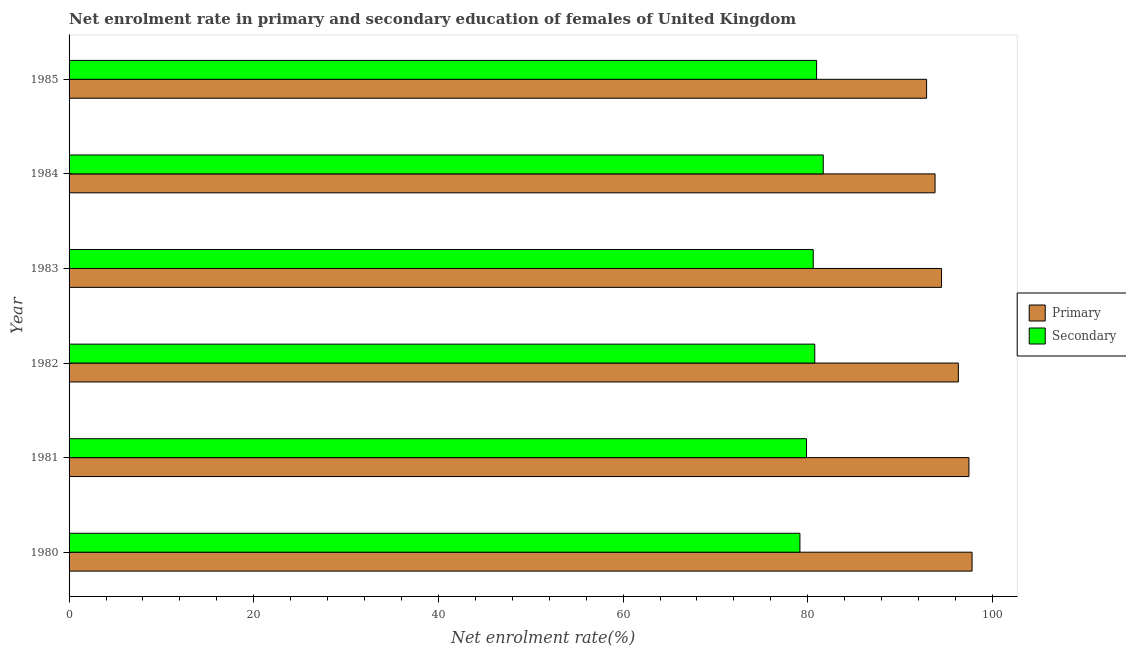How many groups of bars are there?
Your response must be concise. 6. What is the label of the 1st group of bars from the top?
Provide a short and direct response. 1985. What is the enrollment rate in primary education in 1982?
Your answer should be very brief. 96.31. Across all years, what is the maximum enrollment rate in primary education?
Provide a succinct answer. 97.8. Across all years, what is the minimum enrollment rate in secondary education?
Offer a terse response. 79.15. In which year was the enrollment rate in secondary education maximum?
Keep it short and to the point. 1984. In which year was the enrollment rate in secondary education minimum?
Offer a very short reply. 1980. What is the total enrollment rate in secondary education in the graph?
Your answer should be compact. 483.01. What is the difference between the enrollment rate in primary education in 1981 and that in 1983?
Your answer should be compact. 2.97. What is the difference between the enrollment rate in primary education in 1981 and the enrollment rate in secondary education in 1980?
Offer a terse response. 18.3. What is the average enrollment rate in secondary education per year?
Your response must be concise. 80.5. In the year 1981, what is the difference between the enrollment rate in secondary education and enrollment rate in primary education?
Provide a short and direct response. -17.59. What is the ratio of the enrollment rate in secondary education in 1984 to that in 1985?
Your answer should be compact. 1.01. Is the difference between the enrollment rate in secondary education in 1981 and 1984 greater than the difference between the enrollment rate in primary education in 1981 and 1984?
Provide a short and direct response. No. What is the difference between the highest and the second highest enrollment rate in primary education?
Your answer should be compact. 0.34. What is the difference between the highest and the lowest enrollment rate in primary education?
Your response must be concise. 4.92. In how many years, is the enrollment rate in primary education greater than the average enrollment rate in primary education taken over all years?
Provide a short and direct response. 3. Is the sum of the enrollment rate in secondary education in 1980 and 1985 greater than the maximum enrollment rate in primary education across all years?
Make the answer very short. Yes. What does the 1st bar from the top in 1983 represents?
Your answer should be very brief. Secondary. What does the 1st bar from the bottom in 1982 represents?
Offer a very short reply. Primary. Does the graph contain grids?
Provide a short and direct response. No. How are the legend labels stacked?
Provide a succinct answer. Vertical. What is the title of the graph?
Your answer should be very brief. Net enrolment rate in primary and secondary education of females of United Kingdom. What is the label or title of the X-axis?
Ensure brevity in your answer.  Net enrolment rate(%). What is the label or title of the Y-axis?
Your answer should be compact. Year. What is the Net enrolment rate(%) in Primary in 1980?
Keep it short and to the point. 97.8. What is the Net enrolment rate(%) of Secondary in 1980?
Offer a very short reply. 79.15. What is the Net enrolment rate(%) in Primary in 1981?
Make the answer very short. 97.46. What is the Net enrolment rate(%) in Secondary in 1981?
Provide a succinct answer. 79.87. What is the Net enrolment rate(%) in Primary in 1982?
Ensure brevity in your answer.  96.31. What is the Net enrolment rate(%) of Secondary in 1982?
Your answer should be very brief. 80.76. What is the Net enrolment rate(%) of Primary in 1983?
Your answer should be very brief. 94.49. What is the Net enrolment rate(%) in Secondary in 1983?
Provide a short and direct response. 80.6. What is the Net enrolment rate(%) in Primary in 1984?
Make the answer very short. 93.79. What is the Net enrolment rate(%) in Secondary in 1984?
Ensure brevity in your answer.  81.68. What is the Net enrolment rate(%) of Primary in 1985?
Offer a very short reply. 92.87. What is the Net enrolment rate(%) in Secondary in 1985?
Keep it short and to the point. 80.96. Across all years, what is the maximum Net enrolment rate(%) of Primary?
Your answer should be very brief. 97.8. Across all years, what is the maximum Net enrolment rate(%) of Secondary?
Ensure brevity in your answer.  81.68. Across all years, what is the minimum Net enrolment rate(%) of Primary?
Offer a very short reply. 92.87. Across all years, what is the minimum Net enrolment rate(%) in Secondary?
Make the answer very short. 79.15. What is the total Net enrolment rate(%) in Primary in the graph?
Make the answer very short. 572.72. What is the total Net enrolment rate(%) of Secondary in the graph?
Your answer should be compact. 483.01. What is the difference between the Net enrolment rate(%) of Primary in 1980 and that in 1981?
Provide a short and direct response. 0.34. What is the difference between the Net enrolment rate(%) in Secondary in 1980 and that in 1981?
Make the answer very short. -0.71. What is the difference between the Net enrolment rate(%) in Primary in 1980 and that in 1982?
Your response must be concise. 1.48. What is the difference between the Net enrolment rate(%) in Secondary in 1980 and that in 1982?
Offer a very short reply. -1.61. What is the difference between the Net enrolment rate(%) of Primary in 1980 and that in 1983?
Ensure brevity in your answer.  3.31. What is the difference between the Net enrolment rate(%) in Secondary in 1980 and that in 1983?
Offer a terse response. -1.44. What is the difference between the Net enrolment rate(%) in Primary in 1980 and that in 1984?
Your answer should be very brief. 4.01. What is the difference between the Net enrolment rate(%) of Secondary in 1980 and that in 1984?
Your response must be concise. -2.53. What is the difference between the Net enrolment rate(%) in Primary in 1980 and that in 1985?
Your answer should be compact. 4.92. What is the difference between the Net enrolment rate(%) in Secondary in 1980 and that in 1985?
Offer a very short reply. -1.8. What is the difference between the Net enrolment rate(%) of Primary in 1981 and that in 1982?
Make the answer very short. 1.15. What is the difference between the Net enrolment rate(%) of Secondary in 1981 and that in 1982?
Your answer should be compact. -0.9. What is the difference between the Net enrolment rate(%) in Primary in 1981 and that in 1983?
Keep it short and to the point. 2.97. What is the difference between the Net enrolment rate(%) in Secondary in 1981 and that in 1983?
Make the answer very short. -0.73. What is the difference between the Net enrolment rate(%) in Primary in 1981 and that in 1984?
Your response must be concise. 3.67. What is the difference between the Net enrolment rate(%) in Secondary in 1981 and that in 1984?
Ensure brevity in your answer.  -1.81. What is the difference between the Net enrolment rate(%) of Primary in 1981 and that in 1985?
Provide a short and direct response. 4.59. What is the difference between the Net enrolment rate(%) of Secondary in 1981 and that in 1985?
Your response must be concise. -1.09. What is the difference between the Net enrolment rate(%) in Primary in 1982 and that in 1983?
Ensure brevity in your answer.  1.82. What is the difference between the Net enrolment rate(%) of Secondary in 1982 and that in 1983?
Keep it short and to the point. 0.17. What is the difference between the Net enrolment rate(%) in Primary in 1982 and that in 1984?
Provide a short and direct response. 2.52. What is the difference between the Net enrolment rate(%) in Secondary in 1982 and that in 1984?
Offer a very short reply. -0.92. What is the difference between the Net enrolment rate(%) of Primary in 1982 and that in 1985?
Keep it short and to the point. 3.44. What is the difference between the Net enrolment rate(%) of Secondary in 1982 and that in 1985?
Your response must be concise. -0.19. What is the difference between the Net enrolment rate(%) in Primary in 1983 and that in 1984?
Offer a very short reply. 0.7. What is the difference between the Net enrolment rate(%) in Secondary in 1983 and that in 1984?
Provide a succinct answer. -1.08. What is the difference between the Net enrolment rate(%) of Primary in 1983 and that in 1985?
Provide a succinct answer. 1.62. What is the difference between the Net enrolment rate(%) in Secondary in 1983 and that in 1985?
Offer a terse response. -0.36. What is the difference between the Net enrolment rate(%) in Primary in 1984 and that in 1985?
Keep it short and to the point. 0.91. What is the difference between the Net enrolment rate(%) in Secondary in 1984 and that in 1985?
Your response must be concise. 0.72. What is the difference between the Net enrolment rate(%) in Primary in 1980 and the Net enrolment rate(%) in Secondary in 1981?
Make the answer very short. 17.93. What is the difference between the Net enrolment rate(%) of Primary in 1980 and the Net enrolment rate(%) of Secondary in 1982?
Keep it short and to the point. 17.03. What is the difference between the Net enrolment rate(%) in Primary in 1980 and the Net enrolment rate(%) in Secondary in 1983?
Provide a short and direct response. 17.2. What is the difference between the Net enrolment rate(%) of Primary in 1980 and the Net enrolment rate(%) of Secondary in 1984?
Provide a succinct answer. 16.12. What is the difference between the Net enrolment rate(%) of Primary in 1980 and the Net enrolment rate(%) of Secondary in 1985?
Ensure brevity in your answer.  16.84. What is the difference between the Net enrolment rate(%) of Primary in 1981 and the Net enrolment rate(%) of Secondary in 1982?
Your answer should be compact. 16.69. What is the difference between the Net enrolment rate(%) of Primary in 1981 and the Net enrolment rate(%) of Secondary in 1983?
Your answer should be compact. 16.86. What is the difference between the Net enrolment rate(%) in Primary in 1981 and the Net enrolment rate(%) in Secondary in 1984?
Provide a short and direct response. 15.78. What is the difference between the Net enrolment rate(%) of Primary in 1981 and the Net enrolment rate(%) of Secondary in 1985?
Keep it short and to the point. 16.5. What is the difference between the Net enrolment rate(%) of Primary in 1982 and the Net enrolment rate(%) of Secondary in 1983?
Provide a short and direct response. 15.72. What is the difference between the Net enrolment rate(%) in Primary in 1982 and the Net enrolment rate(%) in Secondary in 1984?
Keep it short and to the point. 14.63. What is the difference between the Net enrolment rate(%) of Primary in 1982 and the Net enrolment rate(%) of Secondary in 1985?
Offer a very short reply. 15.35. What is the difference between the Net enrolment rate(%) in Primary in 1983 and the Net enrolment rate(%) in Secondary in 1984?
Your answer should be very brief. 12.81. What is the difference between the Net enrolment rate(%) of Primary in 1983 and the Net enrolment rate(%) of Secondary in 1985?
Keep it short and to the point. 13.53. What is the difference between the Net enrolment rate(%) in Primary in 1984 and the Net enrolment rate(%) in Secondary in 1985?
Offer a very short reply. 12.83. What is the average Net enrolment rate(%) of Primary per year?
Provide a short and direct response. 95.45. What is the average Net enrolment rate(%) of Secondary per year?
Keep it short and to the point. 80.5. In the year 1980, what is the difference between the Net enrolment rate(%) in Primary and Net enrolment rate(%) in Secondary?
Your answer should be very brief. 18.64. In the year 1981, what is the difference between the Net enrolment rate(%) in Primary and Net enrolment rate(%) in Secondary?
Provide a succinct answer. 17.59. In the year 1982, what is the difference between the Net enrolment rate(%) of Primary and Net enrolment rate(%) of Secondary?
Keep it short and to the point. 15.55. In the year 1983, what is the difference between the Net enrolment rate(%) in Primary and Net enrolment rate(%) in Secondary?
Your answer should be very brief. 13.9. In the year 1984, what is the difference between the Net enrolment rate(%) of Primary and Net enrolment rate(%) of Secondary?
Your answer should be compact. 12.11. In the year 1985, what is the difference between the Net enrolment rate(%) of Primary and Net enrolment rate(%) of Secondary?
Make the answer very short. 11.92. What is the ratio of the Net enrolment rate(%) in Secondary in 1980 to that in 1981?
Your answer should be very brief. 0.99. What is the ratio of the Net enrolment rate(%) of Primary in 1980 to that in 1982?
Your answer should be very brief. 1.02. What is the ratio of the Net enrolment rate(%) of Secondary in 1980 to that in 1982?
Ensure brevity in your answer.  0.98. What is the ratio of the Net enrolment rate(%) of Primary in 1980 to that in 1983?
Your answer should be compact. 1.03. What is the ratio of the Net enrolment rate(%) in Secondary in 1980 to that in 1983?
Ensure brevity in your answer.  0.98. What is the ratio of the Net enrolment rate(%) in Primary in 1980 to that in 1984?
Provide a short and direct response. 1.04. What is the ratio of the Net enrolment rate(%) in Secondary in 1980 to that in 1984?
Make the answer very short. 0.97. What is the ratio of the Net enrolment rate(%) of Primary in 1980 to that in 1985?
Your answer should be very brief. 1.05. What is the ratio of the Net enrolment rate(%) in Secondary in 1980 to that in 1985?
Make the answer very short. 0.98. What is the ratio of the Net enrolment rate(%) in Primary in 1981 to that in 1982?
Provide a short and direct response. 1.01. What is the ratio of the Net enrolment rate(%) in Secondary in 1981 to that in 1982?
Offer a terse response. 0.99. What is the ratio of the Net enrolment rate(%) of Primary in 1981 to that in 1983?
Your answer should be compact. 1.03. What is the ratio of the Net enrolment rate(%) in Primary in 1981 to that in 1984?
Offer a very short reply. 1.04. What is the ratio of the Net enrolment rate(%) in Secondary in 1981 to that in 1984?
Your answer should be compact. 0.98. What is the ratio of the Net enrolment rate(%) of Primary in 1981 to that in 1985?
Offer a terse response. 1.05. What is the ratio of the Net enrolment rate(%) in Secondary in 1981 to that in 1985?
Your answer should be compact. 0.99. What is the ratio of the Net enrolment rate(%) in Primary in 1982 to that in 1983?
Provide a short and direct response. 1.02. What is the ratio of the Net enrolment rate(%) in Secondary in 1982 to that in 1983?
Offer a terse response. 1. What is the ratio of the Net enrolment rate(%) in Primary in 1982 to that in 1984?
Ensure brevity in your answer.  1.03. What is the ratio of the Net enrolment rate(%) of Secondary in 1982 to that in 1984?
Give a very brief answer. 0.99. What is the ratio of the Net enrolment rate(%) in Primary in 1982 to that in 1985?
Keep it short and to the point. 1.04. What is the ratio of the Net enrolment rate(%) in Primary in 1983 to that in 1984?
Ensure brevity in your answer.  1.01. What is the ratio of the Net enrolment rate(%) of Secondary in 1983 to that in 1984?
Provide a succinct answer. 0.99. What is the ratio of the Net enrolment rate(%) of Primary in 1983 to that in 1985?
Offer a very short reply. 1.02. What is the ratio of the Net enrolment rate(%) of Primary in 1984 to that in 1985?
Offer a terse response. 1.01. What is the ratio of the Net enrolment rate(%) of Secondary in 1984 to that in 1985?
Your answer should be very brief. 1.01. What is the difference between the highest and the second highest Net enrolment rate(%) in Primary?
Give a very brief answer. 0.34. What is the difference between the highest and the second highest Net enrolment rate(%) in Secondary?
Your answer should be very brief. 0.72. What is the difference between the highest and the lowest Net enrolment rate(%) of Primary?
Your response must be concise. 4.92. What is the difference between the highest and the lowest Net enrolment rate(%) of Secondary?
Ensure brevity in your answer.  2.53. 